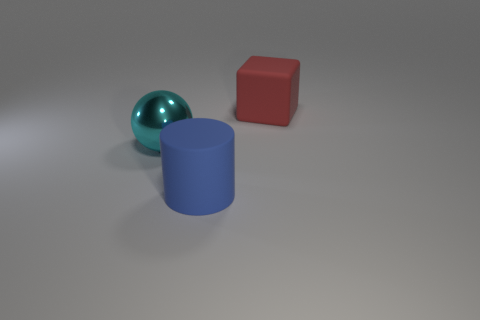What is the size of the object on the left side of the large rubber thing on the left side of the rubber object to the right of the big blue thing?
Your answer should be very brief. Large. What size is the blue cylinder?
Your answer should be very brief. Large. Do the thing in front of the cyan thing and the matte block have the same size?
Your answer should be very brief. Yes. How many other objects are there of the same material as the blue thing?
Make the answer very short. 1. Is the number of big cyan metallic spheres on the right side of the large shiny ball the same as the number of blue cylinders that are on the left side of the cube?
Give a very brief answer. No. What is the color of the large thing on the right side of the big thing that is in front of the large cyan thing that is behind the big cylinder?
Your response must be concise. Red. What shape is the big matte object that is to the right of the big blue object?
Offer a very short reply. Cube. There is a large object that is made of the same material as the cylinder; what is its shape?
Make the answer very short. Cube. Is there any other thing that is the same shape as the blue thing?
Your answer should be very brief. No. There is a blue cylinder; how many large cylinders are in front of it?
Offer a terse response. 0. 